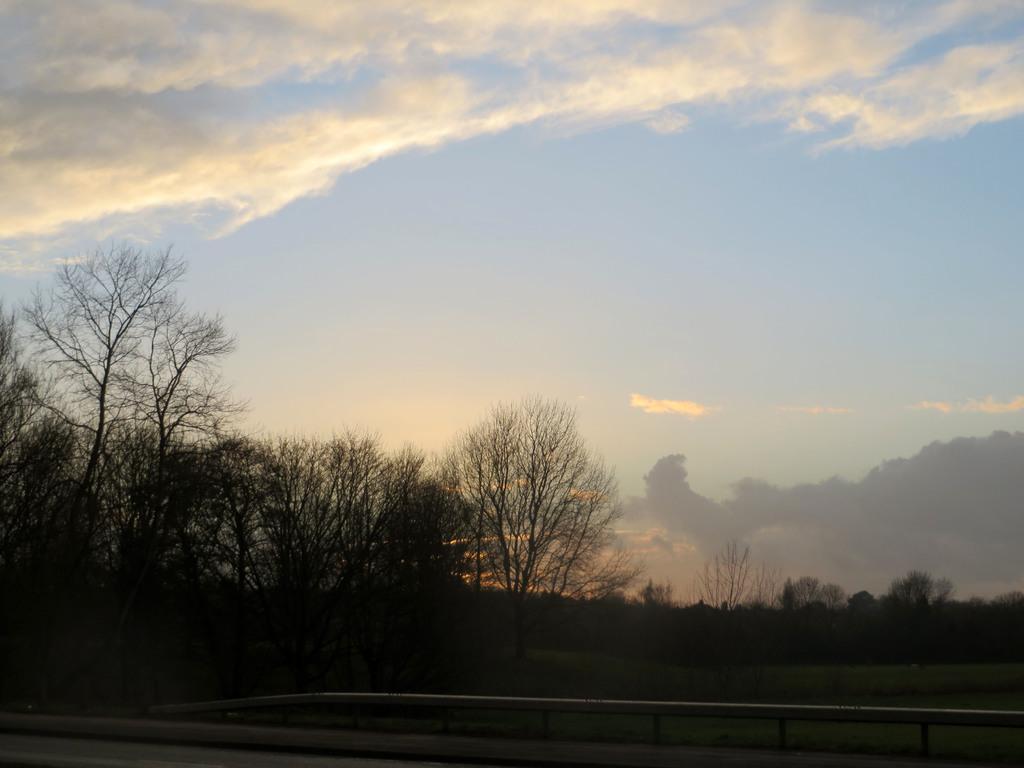Can you describe this image briefly? At the bottom we can see a fence and road. In the background there are trees,plants and clouds in the sky. 